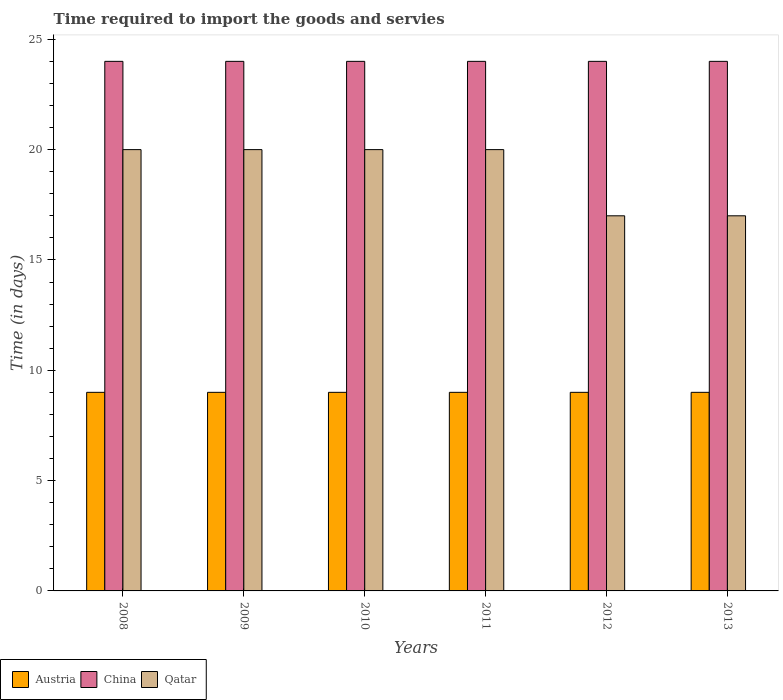How many different coloured bars are there?
Give a very brief answer. 3. In how many cases, is the number of bars for a given year not equal to the number of legend labels?
Make the answer very short. 0. What is the number of days required to import the goods and services in China in 2013?
Keep it short and to the point. 24. Across all years, what is the maximum number of days required to import the goods and services in Austria?
Ensure brevity in your answer.  9. Across all years, what is the minimum number of days required to import the goods and services in China?
Your answer should be compact. 24. In which year was the number of days required to import the goods and services in China maximum?
Keep it short and to the point. 2008. In which year was the number of days required to import the goods and services in Qatar minimum?
Give a very brief answer. 2012. What is the total number of days required to import the goods and services in Austria in the graph?
Offer a terse response. 54. In the year 2011, what is the difference between the number of days required to import the goods and services in China and number of days required to import the goods and services in Qatar?
Provide a short and direct response. 4. In how many years, is the number of days required to import the goods and services in China greater than 10 days?
Offer a very short reply. 6. Is the number of days required to import the goods and services in Austria in 2008 less than that in 2010?
Provide a succinct answer. No. What is the difference between the highest and the second highest number of days required to import the goods and services in Austria?
Your answer should be very brief. 0. In how many years, is the number of days required to import the goods and services in China greater than the average number of days required to import the goods and services in China taken over all years?
Offer a terse response. 0. What does the 2nd bar from the left in 2012 represents?
Make the answer very short. China. What does the 1st bar from the right in 2012 represents?
Ensure brevity in your answer.  Qatar. How many bars are there?
Give a very brief answer. 18. What is the difference between two consecutive major ticks on the Y-axis?
Offer a very short reply. 5. Are the values on the major ticks of Y-axis written in scientific E-notation?
Keep it short and to the point. No. How are the legend labels stacked?
Ensure brevity in your answer.  Horizontal. What is the title of the graph?
Your answer should be compact. Time required to import the goods and servies. What is the label or title of the Y-axis?
Your response must be concise. Time (in days). What is the Time (in days) in Austria in 2008?
Your response must be concise. 9. What is the Time (in days) in Austria in 2010?
Provide a succinct answer. 9. What is the Time (in days) of China in 2010?
Keep it short and to the point. 24. What is the Time (in days) of Qatar in 2011?
Keep it short and to the point. 20. What is the Time (in days) in Austria in 2012?
Give a very brief answer. 9. What is the Time (in days) of China in 2012?
Your response must be concise. 24. What is the Time (in days) of Qatar in 2012?
Give a very brief answer. 17. What is the Time (in days) of Austria in 2013?
Provide a short and direct response. 9. Across all years, what is the maximum Time (in days) of Qatar?
Give a very brief answer. 20. Across all years, what is the minimum Time (in days) in Austria?
Give a very brief answer. 9. What is the total Time (in days) of China in the graph?
Your response must be concise. 144. What is the total Time (in days) of Qatar in the graph?
Give a very brief answer. 114. What is the difference between the Time (in days) in China in 2008 and that in 2009?
Provide a short and direct response. 0. What is the difference between the Time (in days) of Qatar in 2008 and that in 2009?
Provide a succinct answer. 0. What is the difference between the Time (in days) of Austria in 2008 and that in 2010?
Provide a short and direct response. 0. What is the difference between the Time (in days) of China in 2008 and that in 2010?
Provide a succinct answer. 0. What is the difference between the Time (in days) in China in 2008 and that in 2011?
Keep it short and to the point. 0. What is the difference between the Time (in days) of Qatar in 2008 and that in 2011?
Your answer should be very brief. 0. What is the difference between the Time (in days) in Austria in 2008 and that in 2012?
Make the answer very short. 0. What is the difference between the Time (in days) of Qatar in 2008 and that in 2012?
Give a very brief answer. 3. What is the difference between the Time (in days) in Austria in 2008 and that in 2013?
Make the answer very short. 0. What is the difference between the Time (in days) in Qatar in 2009 and that in 2011?
Ensure brevity in your answer.  0. What is the difference between the Time (in days) of Austria in 2009 and that in 2012?
Give a very brief answer. 0. What is the difference between the Time (in days) in Qatar in 2009 and that in 2012?
Make the answer very short. 3. What is the difference between the Time (in days) in Austria in 2009 and that in 2013?
Provide a succinct answer. 0. What is the difference between the Time (in days) of Qatar in 2009 and that in 2013?
Your answer should be compact. 3. What is the difference between the Time (in days) of Austria in 2010 and that in 2011?
Offer a terse response. 0. What is the difference between the Time (in days) of China in 2010 and that in 2012?
Offer a very short reply. 0. What is the difference between the Time (in days) of Austria in 2010 and that in 2013?
Make the answer very short. 0. What is the difference between the Time (in days) in Qatar in 2010 and that in 2013?
Provide a short and direct response. 3. What is the difference between the Time (in days) in China in 2011 and that in 2012?
Your answer should be compact. 0. What is the difference between the Time (in days) in Qatar in 2011 and that in 2012?
Provide a succinct answer. 3. What is the difference between the Time (in days) in Austria in 2011 and that in 2013?
Provide a short and direct response. 0. What is the difference between the Time (in days) in Qatar in 2012 and that in 2013?
Offer a terse response. 0. What is the difference between the Time (in days) of Austria in 2008 and the Time (in days) of Qatar in 2009?
Make the answer very short. -11. What is the difference between the Time (in days) of China in 2008 and the Time (in days) of Qatar in 2009?
Your answer should be very brief. 4. What is the difference between the Time (in days) of Austria in 2008 and the Time (in days) of China in 2011?
Your answer should be compact. -15. What is the difference between the Time (in days) of Austria in 2008 and the Time (in days) of Qatar in 2011?
Keep it short and to the point. -11. What is the difference between the Time (in days) in Austria in 2008 and the Time (in days) in Qatar in 2012?
Keep it short and to the point. -8. What is the difference between the Time (in days) in China in 2008 and the Time (in days) in Qatar in 2013?
Provide a succinct answer. 7. What is the difference between the Time (in days) of Austria in 2009 and the Time (in days) of Qatar in 2012?
Make the answer very short. -8. What is the difference between the Time (in days) of Austria in 2009 and the Time (in days) of Qatar in 2013?
Keep it short and to the point. -8. What is the difference between the Time (in days) of China in 2010 and the Time (in days) of Qatar in 2011?
Ensure brevity in your answer.  4. What is the difference between the Time (in days) of Austria in 2010 and the Time (in days) of Qatar in 2012?
Your response must be concise. -8. What is the difference between the Time (in days) in China in 2010 and the Time (in days) in Qatar in 2012?
Make the answer very short. 7. What is the difference between the Time (in days) in Austria in 2010 and the Time (in days) in China in 2013?
Your answer should be very brief. -15. What is the difference between the Time (in days) of China in 2010 and the Time (in days) of Qatar in 2013?
Provide a succinct answer. 7. What is the difference between the Time (in days) in Austria in 2011 and the Time (in days) in Qatar in 2012?
Your answer should be compact. -8. What is the difference between the Time (in days) of Austria in 2011 and the Time (in days) of China in 2013?
Offer a very short reply. -15. What is the difference between the Time (in days) of China in 2011 and the Time (in days) of Qatar in 2013?
Make the answer very short. 7. What is the difference between the Time (in days) in Austria in 2012 and the Time (in days) in China in 2013?
Make the answer very short. -15. What is the average Time (in days) of Austria per year?
Give a very brief answer. 9. What is the average Time (in days) of China per year?
Your answer should be very brief. 24. In the year 2008, what is the difference between the Time (in days) of Austria and Time (in days) of Qatar?
Provide a succinct answer. -11. In the year 2008, what is the difference between the Time (in days) of China and Time (in days) of Qatar?
Keep it short and to the point. 4. In the year 2009, what is the difference between the Time (in days) of China and Time (in days) of Qatar?
Offer a terse response. 4. In the year 2010, what is the difference between the Time (in days) of Austria and Time (in days) of Qatar?
Provide a succinct answer. -11. In the year 2012, what is the difference between the Time (in days) of Austria and Time (in days) of China?
Ensure brevity in your answer.  -15. In the year 2012, what is the difference between the Time (in days) of China and Time (in days) of Qatar?
Your response must be concise. 7. In the year 2013, what is the difference between the Time (in days) in Austria and Time (in days) in China?
Provide a short and direct response. -15. In the year 2013, what is the difference between the Time (in days) in China and Time (in days) in Qatar?
Your response must be concise. 7. What is the ratio of the Time (in days) in Austria in 2008 to that in 2009?
Your answer should be compact. 1. What is the ratio of the Time (in days) in China in 2008 to that in 2009?
Make the answer very short. 1. What is the ratio of the Time (in days) in Qatar in 2008 to that in 2009?
Offer a very short reply. 1. What is the ratio of the Time (in days) in China in 2008 to that in 2010?
Provide a succinct answer. 1. What is the ratio of the Time (in days) in Qatar in 2008 to that in 2011?
Keep it short and to the point. 1. What is the ratio of the Time (in days) of Austria in 2008 to that in 2012?
Provide a succinct answer. 1. What is the ratio of the Time (in days) of China in 2008 to that in 2012?
Give a very brief answer. 1. What is the ratio of the Time (in days) of Qatar in 2008 to that in 2012?
Make the answer very short. 1.18. What is the ratio of the Time (in days) of Austria in 2008 to that in 2013?
Offer a terse response. 1. What is the ratio of the Time (in days) in China in 2008 to that in 2013?
Provide a short and direct response. 1. What is the ratio of the Time (in days) in Qatar in 2008 to that in 2013?
Provide a short and direct response. 1.18. What is the ratio of the Time (in days) of Austria in 2009 to that in 2011?
Make the answer very short. 1. What is the ratio of the Time (in days) in China in 2009 to that in 2011?
Offer a terse response. 1. What is the ratio of the Time (in days) of Qatar in 2009 to that in 2011?
Provide a succinct answer. 1. What is the ratio of the Time (in days) of China in 2009 to that in 2012?
Make the answer very short. 1. What is the ratio of the Time (in days) of Qatar in 2009 to that in 2012?
Give a very brief answer. 1.18. What is the ratio of the Time (in days) of China in 2009 to that in 2013?
Provide a short and direct response. 1. What is the ratio of the Time (in days) of Qatar in 2009 to that in 2013?
Offer a very short reply. 1.18. What is the ratio of the Time (in days) in Austria in 2010 to that in 2011?
Ensure brevity in your answer.  1. What is the ratio of the Time (in days) of China in 2010 to that in 2011?
Make the answer very short. 1. What is the ratio of the Time (in days) of Qatar in 2010 to that in 2011?
Give a very brief answer. 1. What is the ratio of the Time (in days) of Austria in 2010 to that in 2012?
Offer a very short reply. 1. What is the ratio of the Time (in days) in Qatar in 2010 to that in 2012?
Give a very brief answer. 1.18. What is the ratio of the Time (in days) of Austria in 2010 to that in 2013?
Your response must be concise. 1. What is the ratio of the Time (in days) of Qatar in 2010 to that in 2013?
Your answer should be very brief. 1.18. What is the ratio of the Time (in days) of China in 2011 to that in 2012?
Your answer should be very brief. 1. What is the ratio of the Time (in days) of Qatar in 2011 to that in 2012?
Offer a very short reply. 1.18. What is the ratio of the Time (in days) in China in 2011 to that in 2013?
Provide a succinct answer. 1. What is the ratio of the Time (in days) of Qatar in 2011 to that in 2013?
Keep it short and to the point. 1.18. What is the difference between the highest and the second highest Time (in days) of Austria?
Ensure brevity in your answer.  0. What is the difference between the highest and the second highest Time (in days) of Qatar?
Your answer should be compact. 0. What is the difference between the highest and the lowest Time (in days) in Qatar?
Give a very brief answer. 3. 